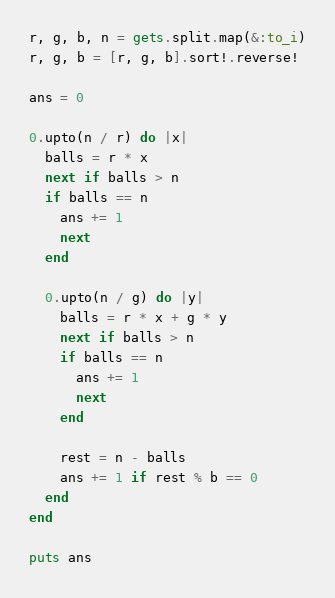<code> <loc_0><loc_0><loc_500><loc_500><_Ruby_>r, g, b, n = gets.split.map(&:to_i)
r, g, b = [r, g, b].sort!.reverse!

ans = 0

0.upto(n / r) do |x|
  balls = r * x
  next if balls > n
  if balls == n
    ans += 1
    next
  end

  0.upto(n / g) do |y|
    balls = r * x + g * y
    next if balls > n
    if balls == n
      ans += 1
      next
    end

    rest = n - balls
    ans += 1 if rest % b == 0
  end
end

puts ans
</code> 